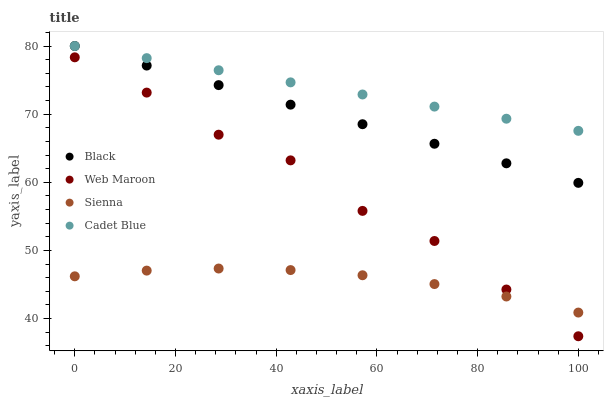Does Sienna have the minimum area under the curve?
Answer yes or no. Yes. Does Cadet Blue have the maximum area under the curve?
Answer yes or no. Yes. Does Web Maroon have the minimum area under the curve?
Answer yes or no. No. Does Web Maroon have the maximum area under the curve?
Answer yes or no. No. Is Cadet Blue the smoothest?
Answer yes or no. Yes. Is Web Maroon the roughest?
Answer yes or no. Yes. Is Web Maroon the smoothest?
Answer yes or no. No. Is Cadet Blue the roughest?
Answer yes or no. No. Does Web Maroon have the lowest value?
Answer yes or no. Yes. Does Cadet Blue have the lowest value?
Answer yes or no. No. Does Black have the highest value?
Answer yes or no. Yes. Does Web Maroon have the highest value?
Answer yes or no. No. Is Sienna less than Black?
Answer yes or no. Yes. Is Black greater than Sienna?
Answer yes or no. Yes. Does Web Maroon intersect Sienna?
Answer yes or no. Yes. Is Web Maroon less than Sienna?
Answer yes or no. No. Is Web Maroon greater than Sienna?
Answer yes or no. No. Does Sienna intersect Black?
Answer yes or no. No. 